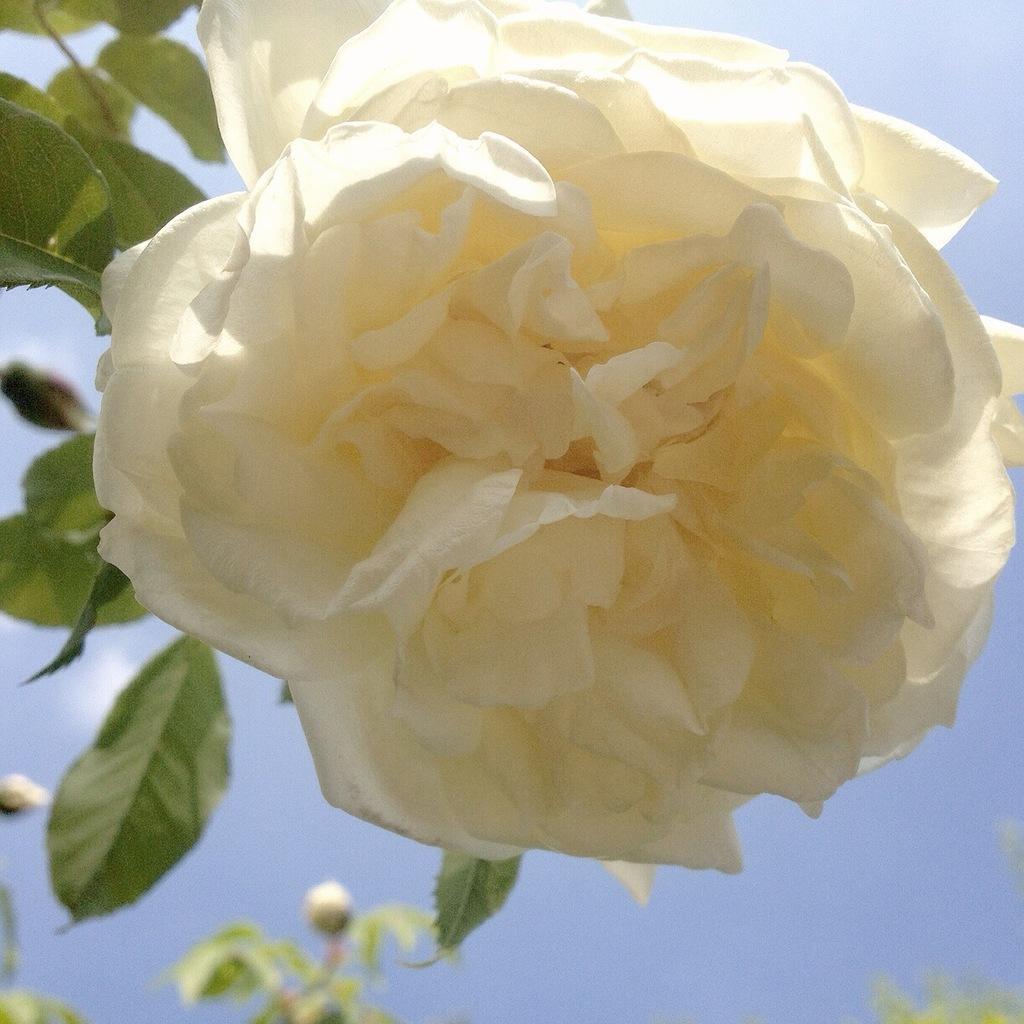In one or two sentences, can you explain what this image depicts? It is a beautiful white color rose flower, there are rose buds at the down to these plants. 